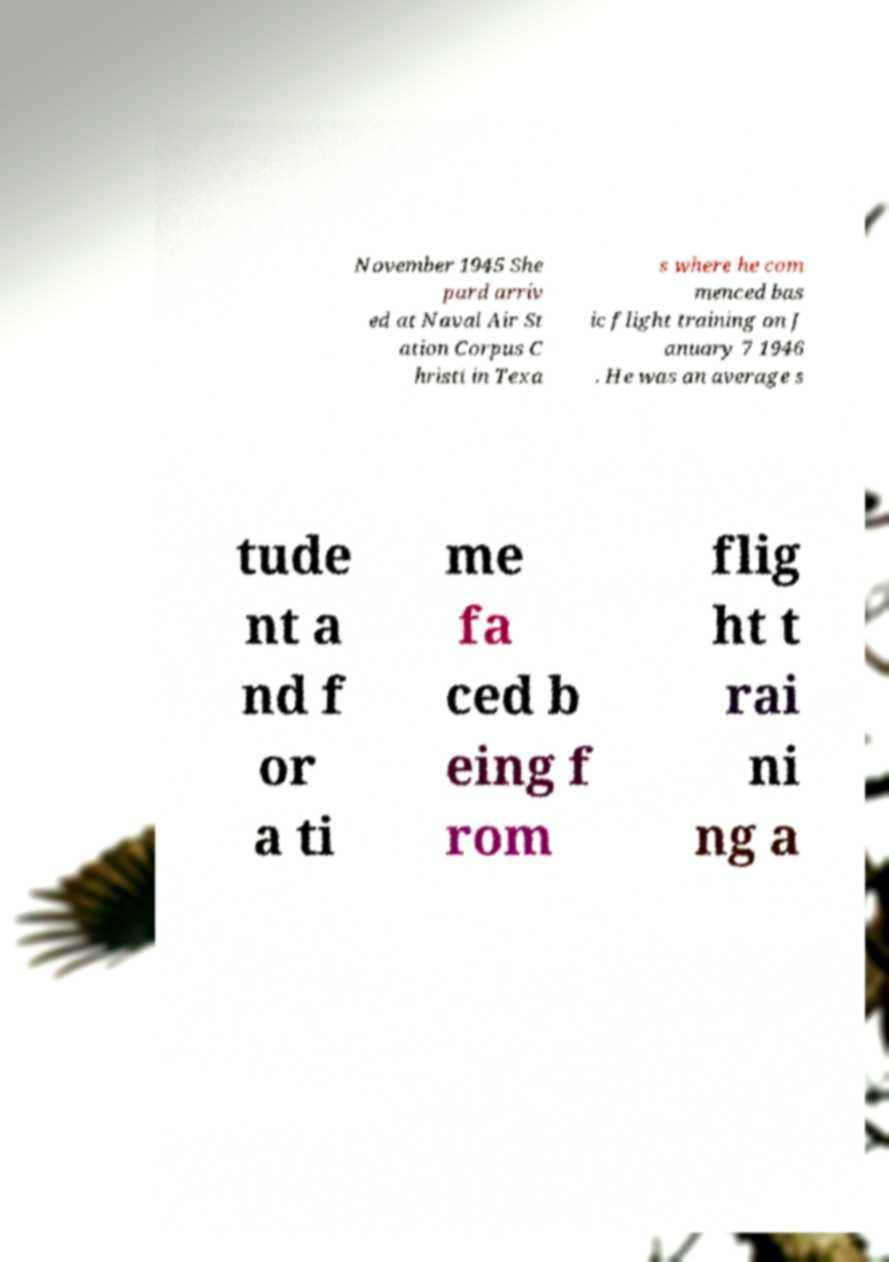Can you read and provide the text displayed in the image?This photo seems to have some interesting text. Can you extract and type it out for me? November 1945 She pard arriv ed at Naval Air St ation Corpus C hristi in Texa s where he com menced bas ic flight training on J anuary 7 1946 . He was an average s tude nt a nd f or a ti me fa ced b eing f rom flig ht t rai ni ng a 